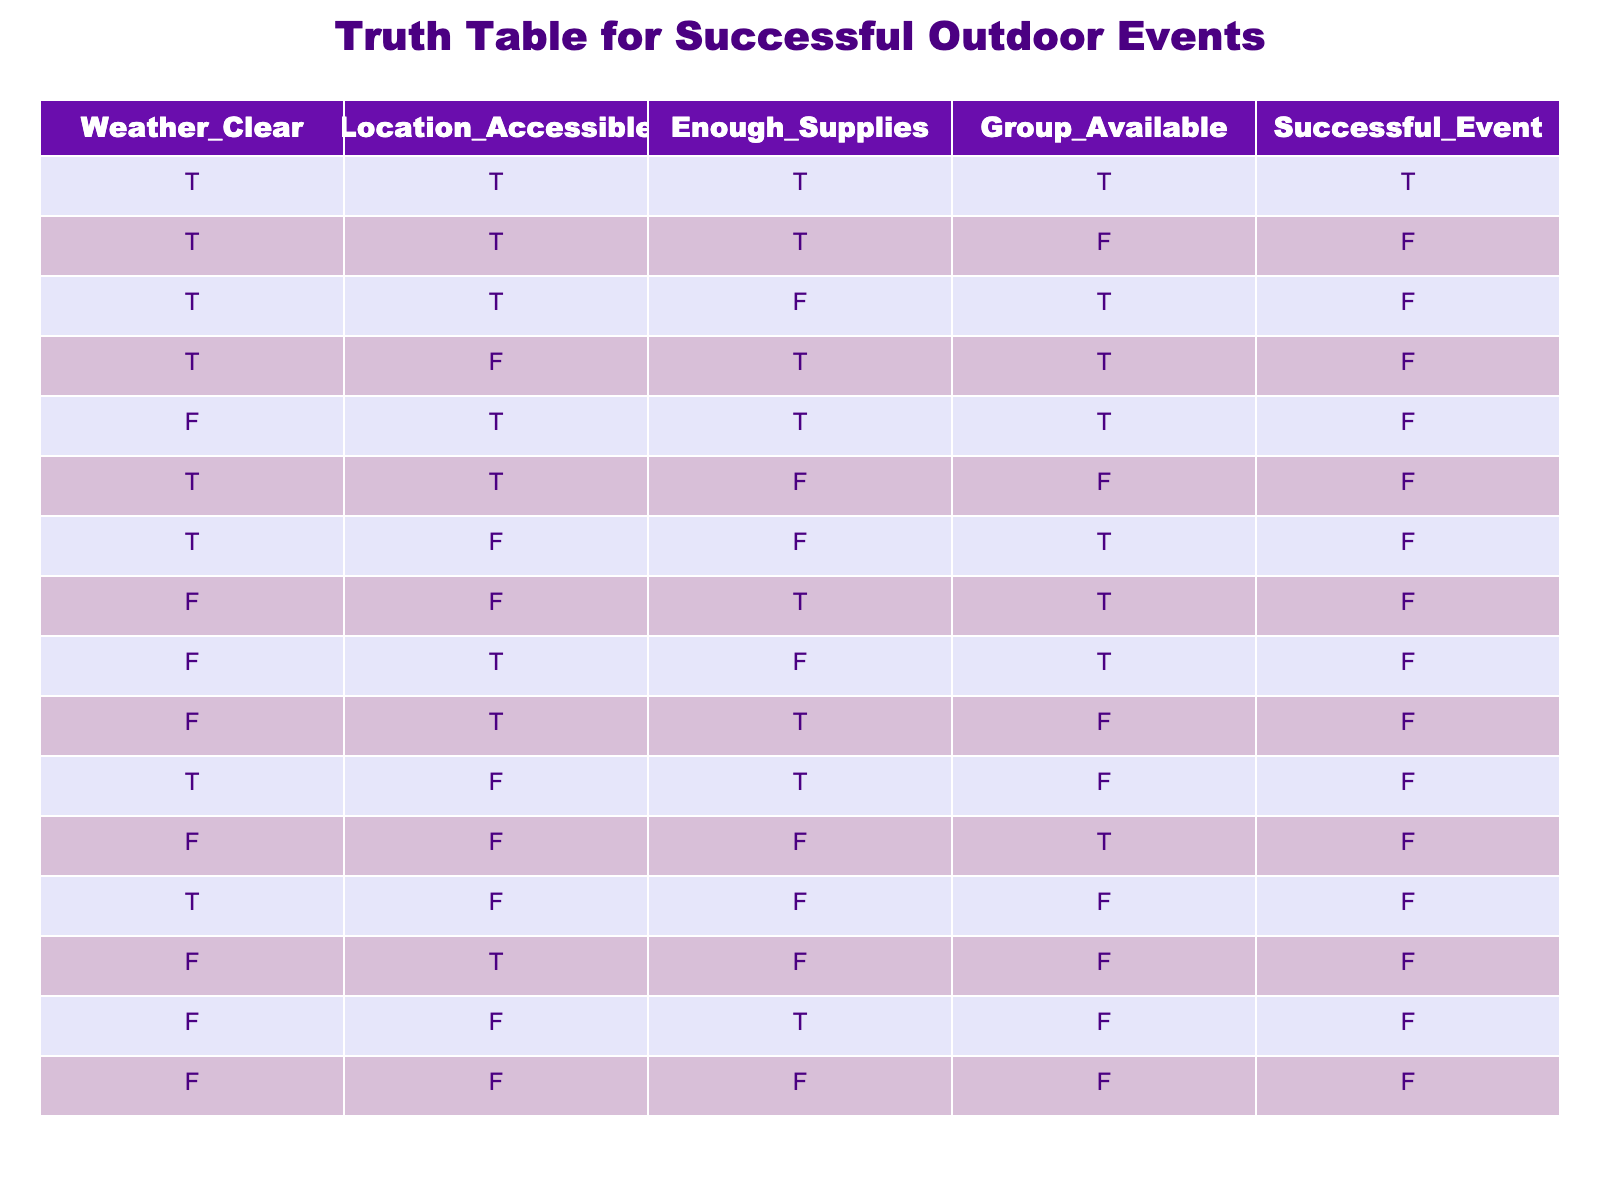What percentage of the events were successful when the weather was clear? There are 8 rows where the weather is clear. Out of these, 5 events were successful. To find the percentage, I calculate (5 successful events / 8 total events) * 100 = 62.5%.
Answer: 62.5% How many events were held in accessible locations that were not successful? From the table, there are 8 rows where the location is accessible. Out of these, 3 events were not successful.
Answer: 3 Is it true that all successful events had enough supplies? Examining the successful events in the table, there are 5 of them. All of these events indeed had enough supplies, as the "Enough Supplies" column is true for all successful events.
Answer: Yes What is the total number of events where the weather was not clear? The table has 8 rows where the weather is not clear (4 of them are false). Therefore, the total number of events not held in clear weather is 8.
Answer: 8 How many successful events were held with group availability and enough supplies? There are 5 successful events, and all of these events also had both group availability and enough supplies. Hence, the total is 5.
Answer: 5 Which combinations of conditions led to unsuccessful events? The table shows 9 rows where events were unsuccessful. Analyzing these, the combinations include: weather clear and incapable, not accessible, supplies, group available, and any mixed factors resulting in failure. This indicates that some factors must have contributed negatively to event success.
Answer: 9 Is it true that an event can be unsuccessful even when the location is accessible and there are enough supplies? According to the table, there are scenarios where the location was accessible and there were enough supplies, but the overall combination led to unsuccessful events. In those instances, both the weather and group availability were not ideal. Thus, it is indeed true.
Answer: Yes What can be inferred about the importance of location accessibility in successful events? Analyzing the successful events shows that all successful outcomes occurred under accessible conditions. This indicates that location accessibility plays a crucial role in the success of outdoor events.
Answer: Location accessibility is crucial 